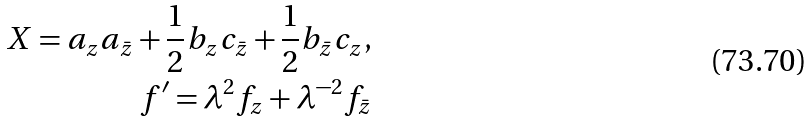<formula> <loc_0><loc_0><loc_500><loc_500>X = a _ { z } a _ { \bar { z } } + \frac { 1 } { 2 } b _ { z } c _ { \bar { z } } + \frac { 1 } { 2 } b _ { \bar { z } } c _ { z } , \\ f ^ { \prime } = \lambda ^ { 2 } f _ { z } + \lambda ^ { - 2 } f _ { \bar { z } }</formula> 